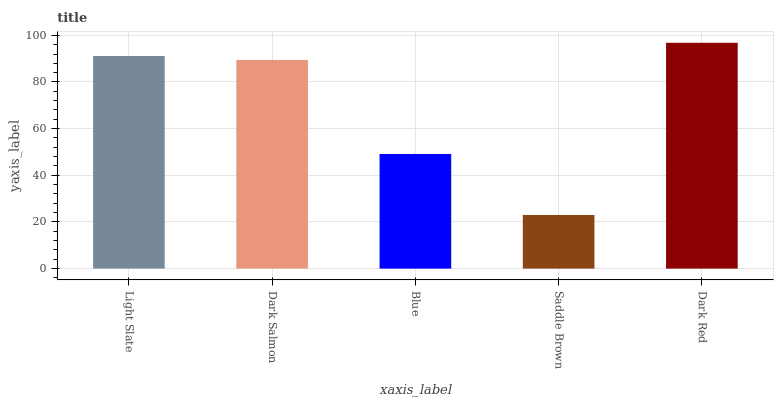Is Saddle Brown the minimum?
Answer yes or no. Yes. Is Dark Red the maximum?
Answer yes or no. Yes. Is Dark Salmon the minimum?
Answer yes or no. No. Is Dark Salmon the maximum?
Answer yes or no. No. Is Light Slate greater than Dark Salmon?
Answer yes or no. Yes. Is Dark Salmon less than Light Slate?
Answer yes or no. Yes. Is Dark Salmon greater than Light Slate?
Answer yes or no. No. Is Light Slate less than Dark Salmon?
Answer yes or no. No. Is Dark Salmon the high median?
Answer yes or no. Yes. Is Dark Salmon the low median?
Answer yes or no. Yes. Is Dark Red the high median?
Answer yes or no. No. Is Saddle Brown the low median?
Answer yes or no. No. 